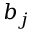<formula> <loc_0><loc_0><loc_500><loc_500>b _ { j }</formula> 